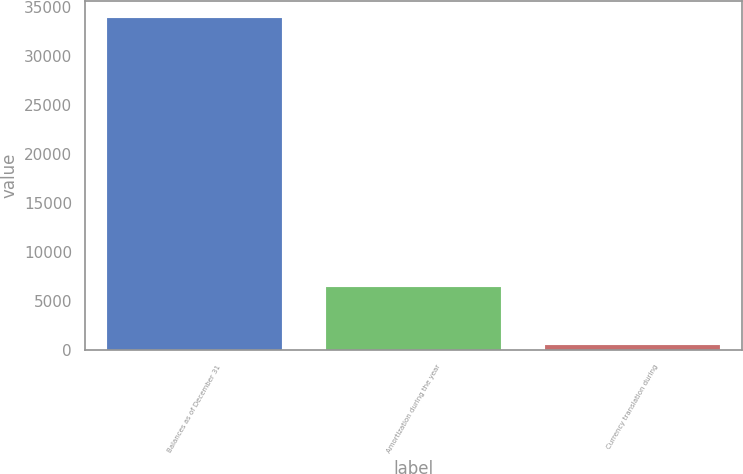Convert chart. <chart><loc_0><loc_0><loc_500><loc_500><bar_chart><fcel>Balances as of December 31<fcel>Amortization during the year<fcel>Currency translation during<nl><fcel>33917<fcel>6456<fcel>548<nl></chart> 